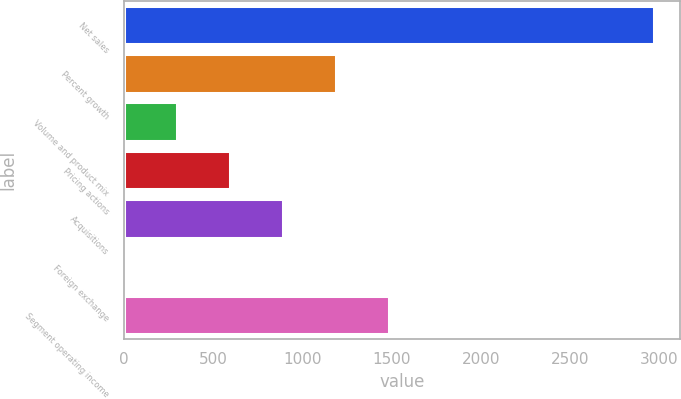<chart> <loc_0><loc_0><loc_500><loc_500><bar_chart><fcel>Net sales<fcel>Percent growth<fcel>Volume and product mix<fcel>Pricing actions<fcel>Acquisitions<fcel>Foreign exchange<fcel>Segment operating income<nl><fcel>2970.1<fcel>1188.1<fcel>297.1<fcel>594.1<fcel>891.1<fcel>0.1<fcel>1485.1<nl></chart> 